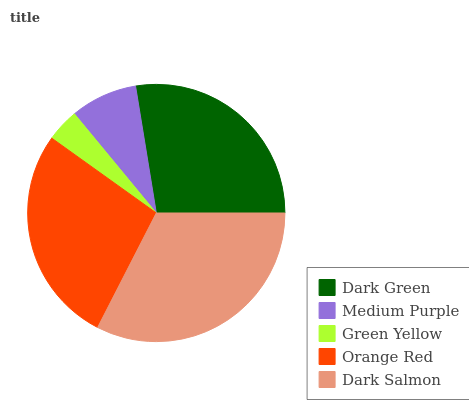Is Green Yellow the minimum?
Answer yes or no. Yes. Is Dark Salmon the maximum?
Answer yes or no. Yes. Is Medium Purple the minimum?
Answer yes or no. No. Is Medium Purple the maximum?
Answer yes or no. No. Is Dark Green greater than Medium Purple?
Answer yes or no. Yes. Is Medium Purple less than Dark Green?
Answer yes or no. Yes. Is Medium Purple greater than Dark Green?
Answer yes or no. No. Is Dark Green less than Medium Purple?
Answer yes or no. No. Is Orange Red the high median?
Answer yes or no. Yes. Is Orange Red the low median?
Answer yes or no. Yes. Is Medium Purple the high median?
Answer yes or no. No. Is Dark Green the low median?
Answer yes or no. No. 